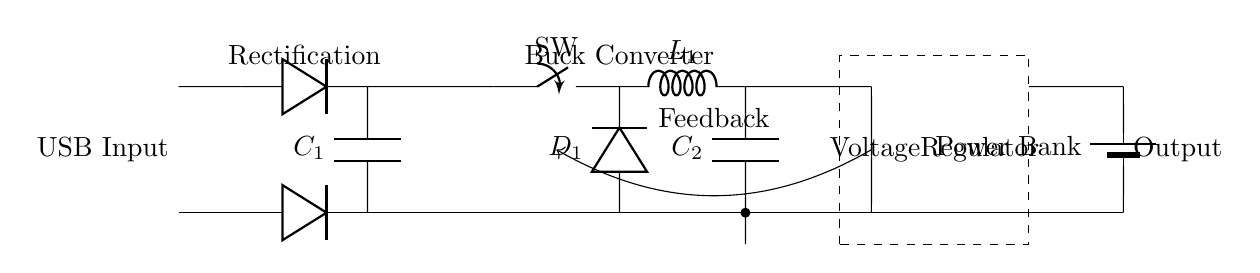What is the input of the circuit? The input is labeled as "USB Input," indicating that the circuit is designed to be powered by a USB source.
Answer: USB Input What component is responsible for voltage regulation? The voltage regulator is a distinct section in the circuit, denoted by a dashed rectangle, which suggests that it is managing the output voltage.
Answer: Voltage Regulator How many capacitors are present in the circuit? There are two capacitors labeled as C1 and C2 in the circuit, one connected to the rectifier and the other associated with the buck converter.
Answer: 2 What type of converter is used in this circuit? The circuit features a buck converter, identifiable by the inductor (L1) and associated switch, responsible for stepping down voltage.
Answer: Buck Converter What does the feedback arrow indicate? The feedback arrow connecting the voltage regulator to the buck converter shows that the regulator is monitoring the output and adjusting the converter's performance accordingly.
Answer: Feedback What type of diode is depicted in the diagram? The circuit shows two diodes labeled as D1, which are typically used for rectification, indicating they allow current to pass in one direction only.
Answer: Diode What is the output labeled as? The output of the circuit is labeled "Power Bank," indicating that the circuit is designed to supply power to a battery or power storage device.
Answer: Power Bank 